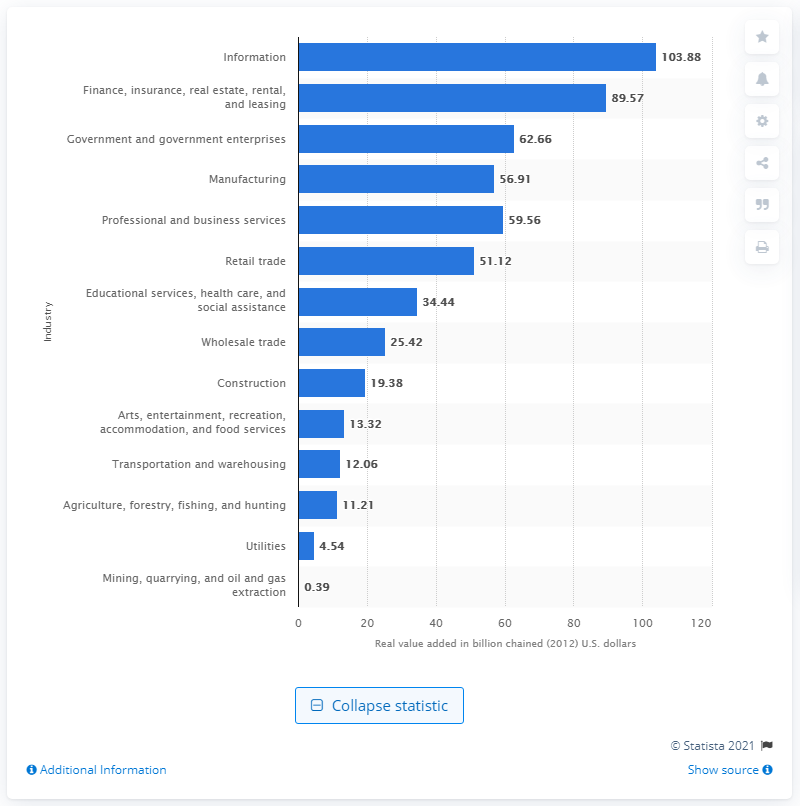Point out several critical features in this image. In 2012, the construction industry contributed a significant amount to Washington's Gross Domestic Product (GDP), with a value of 19.38. 